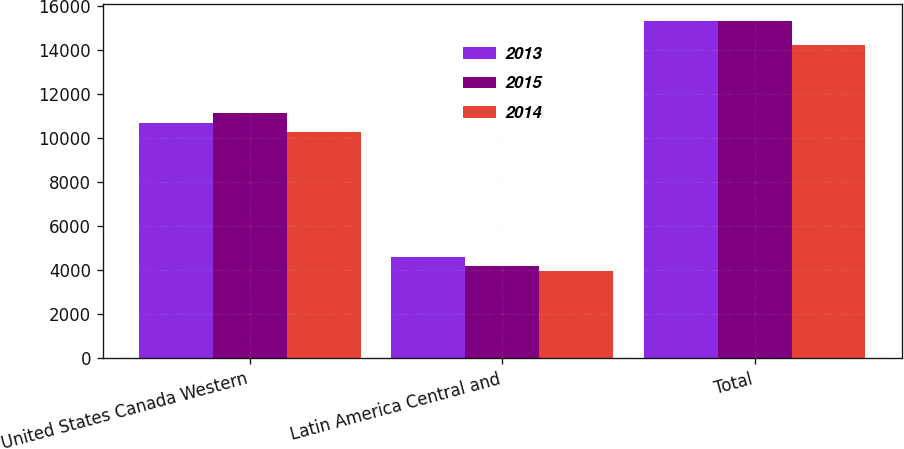Convert chart. <chart><loc_0><loc_0><loc_500><loc_500><stacked_bar_chart><ecel><fcel>United States Canada Western<fcel>Latin America Central and<fcel>Total<nl><fcel>2013<fcel>10708<fcel>4622<fcel>15330<nl><fcel>2015<fcel>11139<fcel>4221<fcel>15360<nl><fcel>2014<fcel>10311<fcel>3954<fcel>14265<nl></chart> 